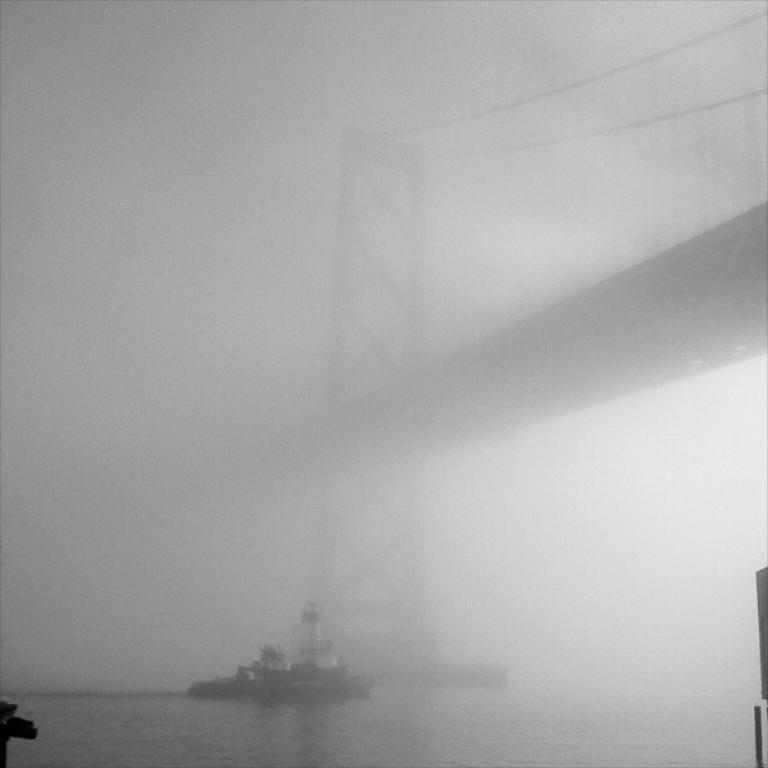What is the main structure in the middle of the picture? There is a bridge in the middle of the picture. What natural feature can be seen in the image? There is a river visible in the image. What type of vehicle is present on the water in the image? A ship is floating on the water in the image. Where is the throne located in the image? There is no throne present in the image. 